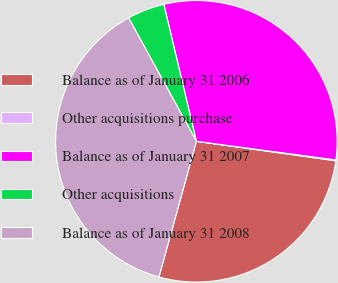Convert chart to OTSL. <chart><loc_0><loc_0><loc_500><loc_500><pie_chart><fcel>Balance as of January 31 2006<fcel>Other acquisitions purchase<fcel>Balance as of January 31 2007<fcel>Other acquisitions<fcel>Balance as of January 31 2008<nl><fcel>27.07%<fcel>0.1%<fcel>30.83%<fcel>4.28%<fcel>37.72%<nl></chart> 